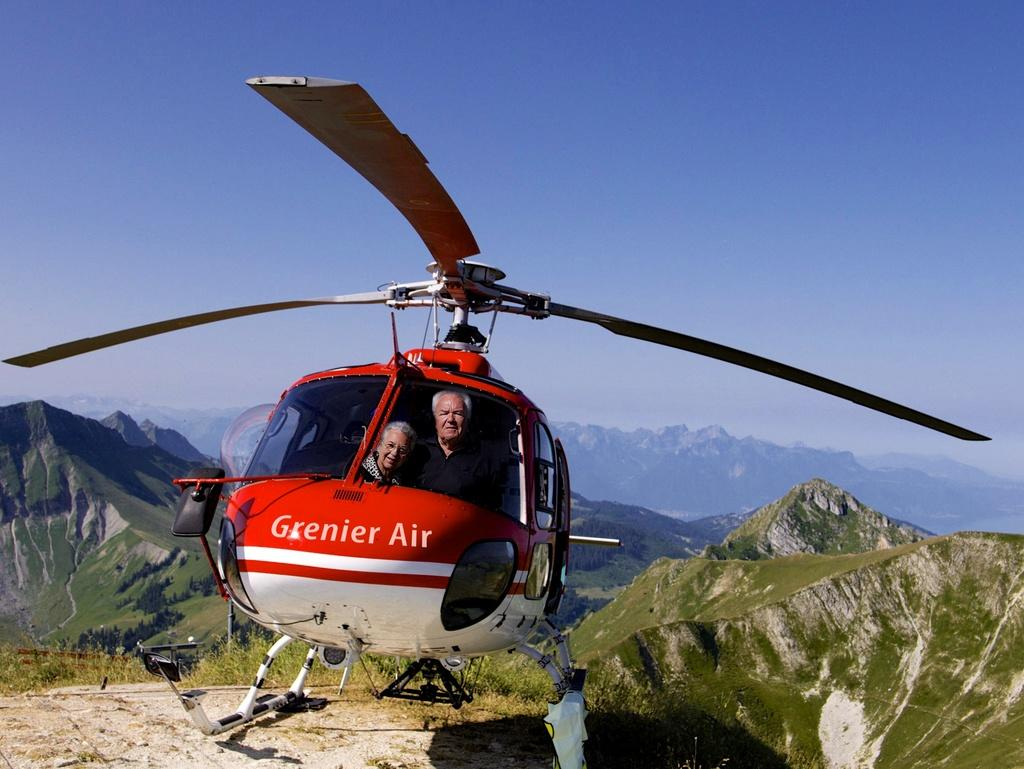What is the main subject of the image? The main subject of the image is an aircraft. What colors are used to paint the aircraft? The aircraft is in white and red colors. How many people are inside the aircraft? There are two persons sitting in the aircraft. What can be seen in the background of the image? There are mountains visible in the background of the image. What is the color of the sky in the image? The sky is blue in the image. Where is the son playing with the box in the image? There is no son or box present in the image; it features an aircraft with two persons inside. 